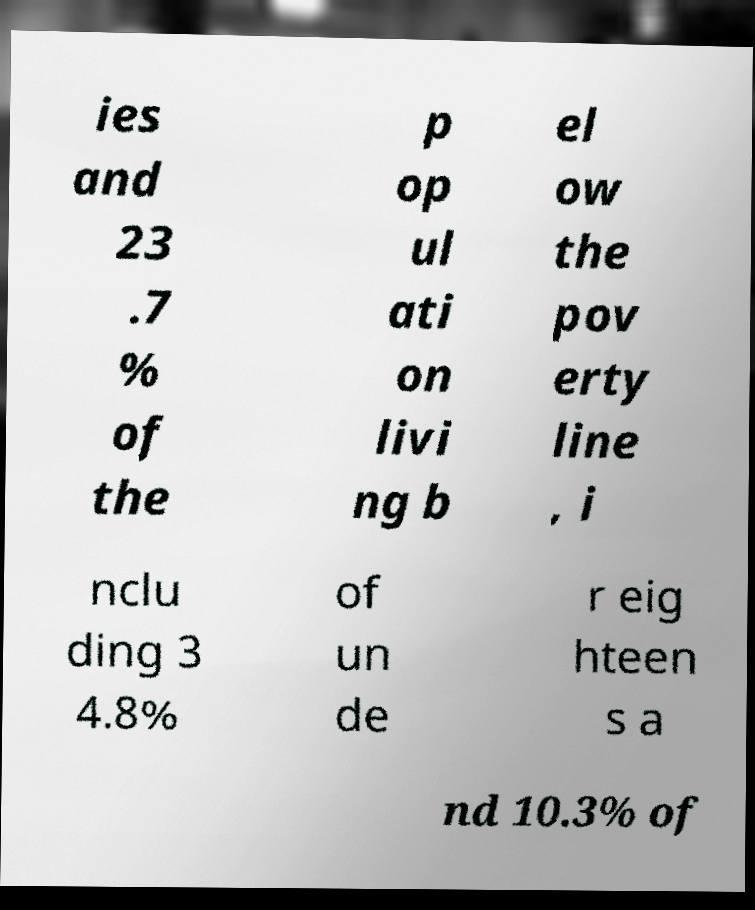I need the written content from this picture converted into text. Can you do that? ies and 23 .7 % of the p op ul ati on livi ng b el ow the pov erty line , i nclu ding 3 4.8% of un de r eig hteen s a nd 10.3% of 